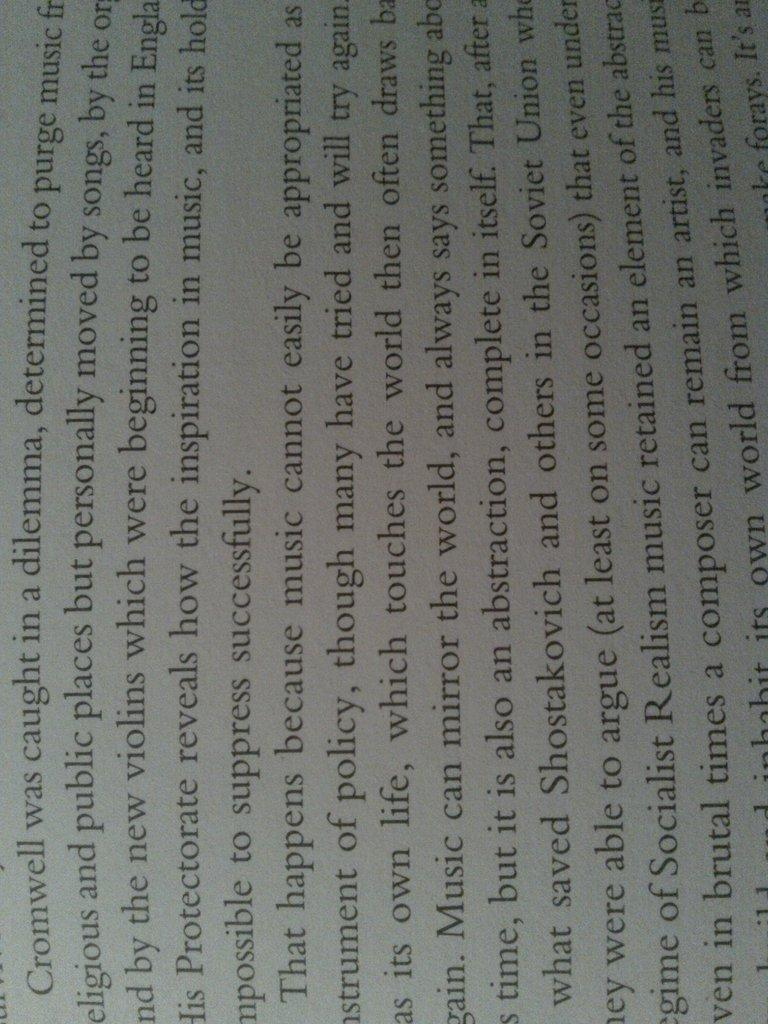<image>
Share a concise interpretation of the image provided. A page from a book that references Cromwell. 